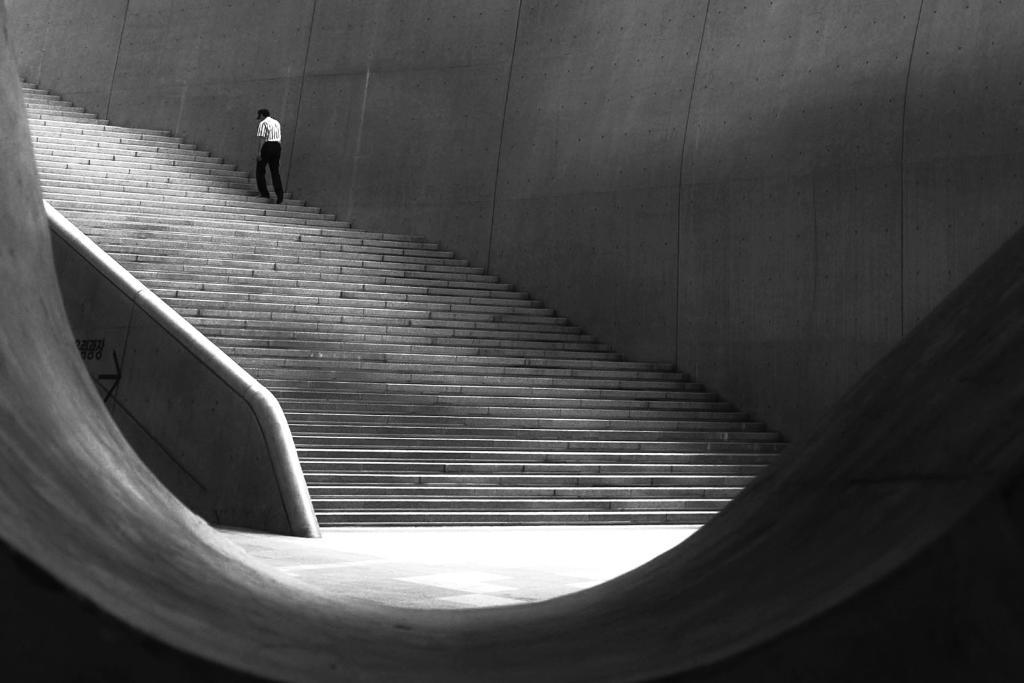Who or what can be seen in the image? There is a person visible in the image. Where is the person located in the image? The person is on the steps. What is beside the person in the image? There is a wall beside the person. What type of behavior can be observed in the person's connection to the transport in the image? There is no transport present in the image, so it is not possible to observe any behavior related to it. 